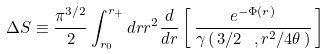Convert formula to latex. <formula><loc_0><loc_0><loc_500><loc_500>\Delta S \equiv \frac { \pi ^ { 3 / 2 } } { 2 } \int _ { r _ { 0 } } ^ { r _ { + } } d r r ^ { 2 } \frac { d } { d r } \left [ \, \frac { e ^ { - \Phi ( r ) } } { \gamma \left ( \, 3 / 2 \ , r ^ { 2 } / 4 \theta \, \right ) } \, \right ]</formula> 